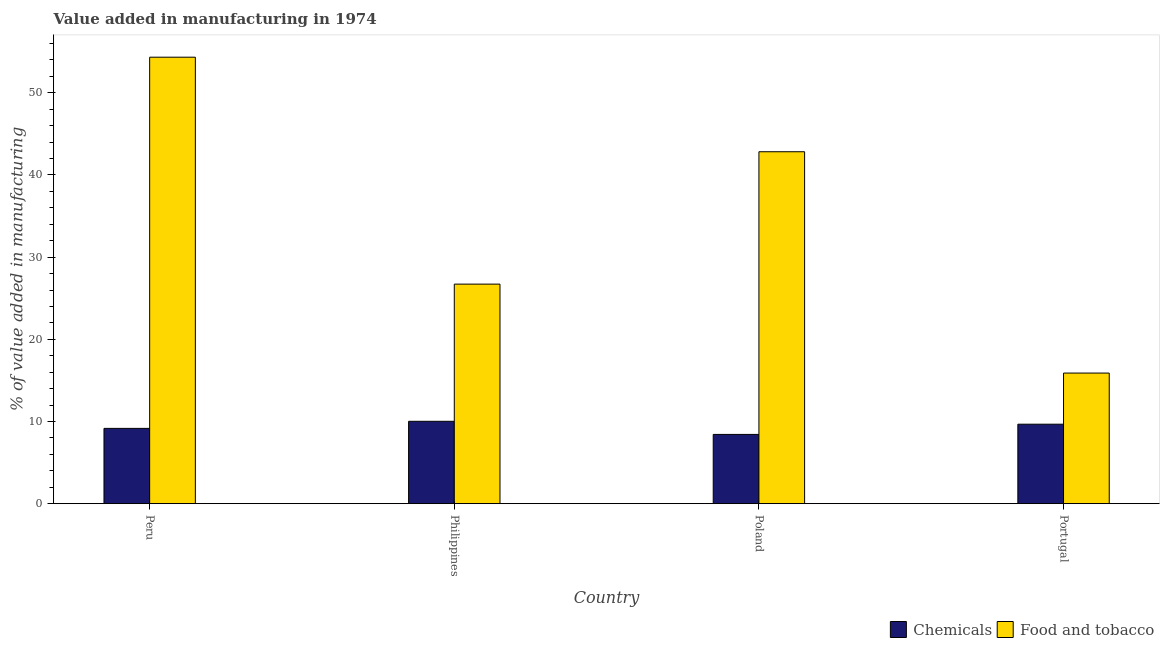How many different coloured bars are there?
Provide a succinct answer. 2. How many groups of bars are there?
Offer a terse response. 4. Are the number of bars on each tick of the X-axis equal?
Give a very brief answer. Yes. How many bars are there on the 2nd tick from the left?
Provide a short and direct response. 2. What is the label of the 3rd group of bars from the left?
Keep it short and to the point. Poland. What is the value added by  manufacturing chemicals in Philippines?
Offer a very short reply. 10.02. Across all countries, what is the maximum value added by manufacturing food and tobacco?
Provide a short and direct response. 54.33. Across all countries, what is the minimum value added by  manufacturing chemicals?
Your response must be concise. 8.43. In which country was the value added by manufacturing food and tobacco maximum?
Provide a short and direct response. Peru. What is the total value added by manufacturing food and tobacco in the graph?
Keep it short and to the point. 139.77. What is the difference between the value added by  manufacturing chemicals in Poland and that in Portugal?
Make the answer very short. -1.24. What is the difference between the value added by manufacturing food and tobacco in Peru and the value added by  manufacturing chemicals in Philippines?
Your response must be concise. 44.31. What is the average value added by  manufacturing chemicals per country?
Your answer should be very brief. 9.32. What is the difference between the value added by  manufacturing chemicals and value added by manufacturing food and tobacco in Portugal?
Your answer should be compact. -6.22. In how many countries, is the value added by  manufacturing chemicals greater than 40 %?
Provide a short and direct response. 0. What is the ratio of the value added by manufacturing food and tobacco in Peru to that in Portugal?
Your response must be concise. 3.42. What is the difference between the highest and the second highest value added by manufacturing food and tobacco?
Your response must be concise. 11.51. What is the difference between the highest and the lowest value added by  manufacturing chemicals?
Provide a short and direct response. 1.59. In how many countries, is the value added by  manufacturing chemicals greater than the average value added by  manufacturing chemicals taken over all countries?
Give a very brief answer. 2. What does the 1st bar from the left in Philippines represents?
Your answer should be very brief. Chemicals. What does the 2nd bar from the right in Peru represents?
Your answer should be compact. Chemicals. Are all the bars in the graph horizontal?
Make the answer very short. No. How many countries are there in the graph?
Your answer should be compact. 4. What is the difference between two consecutive major ticks on the Y-axis?
Provide a short and direct response. 10. Are the values on the major ticks of Y-axis written in scientific E-notation?
Provide a short and direct response. No. Where does the legend appear in the graph?
Make the answer very short. Bottom right. How are the legend labels stacked?
Keep it short and to the point. Horizontal. What is the title of the graph?
Your answer should be very brief. Value added in manufacturing in 1974. What is the label or title of the X-axis?
Offer a very short reply. Country. What is the label or title of the Y-axis?
Ensure brevity in your answer.  % of value added in manufacturing. What is the % of value added in manufacturing of Chemicals in Peru?
Provide a short and direct response. 9.16. What is the % of value added in manufacturing in Food and tobacco in Peru?
Provide a short and direct response. 54.33. What is the % of value added in manufacturing of Chemicals in Philippines?
Ensure brevity in your answer.  10.02. What is the % of value added in manufacturing in Food and tobacco in Philippines?
Your response must be concise. 26.72. What is the % of value added in manufacturing in Chemicals in Poland?
Offer a very short reply. 8.43. What is the % of value added in manufacturing in Food and tobacco in Poland?
Offer a terse response. 42.83. What is the % of value added in manufacturing in Chemicals in Portugal?
Offer a very short reply. 9.67. What is the % of value added in manufacturing in Food and tobacco in Portugal?
Your answer should be compact. 15.89. Across all countries, what is the maximum % of value added in manufacturing of Chemicals?
Your response must be concise. 10.02. Across all countries, what is the maximum % of value added in manufacturing of Food and tobacco?
Offer a terse response. 54.33. Across all countries, what is the minimum % of value added in manufacturing of Chemicals?
Ensure brevity in your answer.  8.43. Across all countries, what is the minimum % of value added in manufacturing of Food and tobacco?
Your answer should be compact. 15.89. What is the total % of value added in manufacturing of Chemicals in the graph?
Ensure brevity in your answer.  37.28. What is the total % of value added in manufacturing of Food and tobacco in the graph?
Your answer should be compact. 139.77. What is the difference between the % of value added in manufacturing in Chemicals in Peru and that in Philippines?
Make the answer very short. -0.86. What is the difference between the % of value added in manufacturing of Food and tobacco in Peru and that in Philippines?
Your response must be concise. 27.61. What is the difference between the % of value added in manufacturing of Chemicals in Peru and that in Poland?
Your response must be concise. 0.73. What is the difference between the % of value added in manufacturing in Food and tobacco in Peru and that in Poland?
Offer a terse response. 11.51. What is the difference between the % of value added in manufacturing of Chemicals in Peru and that in Portugal?
Ensure brevity in your answer.  -0.51. What is the difference between the % of value added in manufacturing of Food and tobacco in Peru and that in Portugal?
Offer a very short reply. 38.44. What is the difference between the % of value added in manufacturing of Chemicals in Philippines and that in Poland?
Ensure brevity in your answer.  1.59. What is the difference between the % of value added in manufacturing of Food and tobacco in Philippines and that in Poland?
Make the answer very short. -16.11. What is the difference between the % of value added in manufacturing of Chemicals in Philippines and that in Portugal?
Offer a terse response. 0.35. What is the difference between the % of value added in manufacturing of Food and tobacco in Philippines and that in Portugal?
Provide a short and direct response. 10.83. What is the difference between the % of value added in manufacturing of Chemicals in Poland and that in Portugal?
Offer a terse response. -1.24. What is the difference between the % of value added in manufacturing of Food and tobacco in Poland and that in Portugal?
Offer a very short reply. 26.94. What is the difference between the % of value added in manufacturing of Chemicals in Peru and the % of value added in manufacturing of Food and tobacco in Philippines?
Your answer should be very brief. -17.56. What is the difference between the % of value added in manufacturing in Chemicals in Peru and the % of value added in manufacturing in Food and tobacco in Poland?
Keep it short and to the point. -33.67. What is the difference between the % of value added in manufacturing in Chemicals in Peru and the % of value added in manufacturing in Food and tobacco in Portugal?
Ensure brevity in your answer.  -6.73. What is the difference between the % of value added in manufacturing of Chemicals in Philippines and the % of value added in manufacturing of Food and tobacco in Poland?
Provide a short and direct response. -32.8. What is the difference between the % of value added in manufacturing of Chemicals in Philippines and the % of value added in manufacturing of Food and tobacco in Portugal?
Your response must be concise. -5.87. What is the difference between the % of value added in manufacturing of Chemicals in Poland and the % of value added in manufacturing of Food and tobacco in Portugal?
Your answer should be very brief. -7.46. What is the average % of value added in manufacturing in Chemicals per country?
Keep it short and to the point. 9.32. What is the average % of value added in manufacturing in Food and tobacco per country?
Provide a succinct answer. 34.94. What is the difference between the % of value added in manufacturing of Chemicals and % of value added in manufacturing of Food and tobacco in Peru?
Provide a short and direct response. -45.17. What is the difference between the % of value added in manufacturing in Chemicals and % of value added in manufacturing in Food and tobacco in Philippines?
Provide a succinct answer. -16.7. What is the difference between the % of value added in manufacturing of Chemicals and % of value added in manufacturing of Food and tobacco in Poland?
Ensure brevity in your answer.  -34.4. What is the difference between the % of value added in manufacturing in Chemicals and % of value added in manufacturing in Food and tobacco in Portugal?
Offer a terse response. -6.22. What is the ratio of the % of value added in manufacturing in Chemicals in Peru to that in Philippines?
Your answer should be very brief. 0.91. What is the ratio of the % of value added in manufacturing in Food and tobacco in Peru to that in Philippines?
Give a very brief answer. 2.03. What is the ratio of the % of value added in manufacturing of Chemicals in Peru to that in Poland?
Your response must be concise. 1.09. What is the ratio of the % of value added in manufacturing of Food and tobacco in Peru to that in Poland?
Offer a terse response. 1.27. What is the ratio of the % of value added in manufacturing of Food and tobacco in Peru to that in Portugal?
Make the answer very short. 3.42. What is the ratio of the % of value added in manufacturing of Chemicals in Philippines to that in Poland?
Your answer should be compact. 1.19. What is the ratio of the % of value added in manufacturing in Food and tobacco in Philippines to that in Poland?
Keep it short and to the point. 0.62. What is the ratio of the % of value added in manufacturing in Chemicals in Philippines to that in Portugal?
Ensure brevity in your answer.  1.04. What is the ratio of the % of value added in manufacturing in Food and tobacco in Philippines to that in Portugal?
Offer a terse response. 1.68. What is the ratio of the % of value added in manufacturing of Chemicals in Poland to that in Portugal?
Give a very brief answer. 0.87. What is the ratio of the % of value added in manufacturing in Food and tobacco in Poland to that in Portugal?
Your answer should be very brief. 2.69. What is the difference between the highest and the second highest % of value added in manufacturing of Chemicals?
Ensure brevity in your answer.  0.35. What is the difference between the highest and the second highest % of value added in manufacturing of Food and tobacco?
Offer a terse response. 11.51. What is the difference between the highest and the lowest % of value added in manufacturing of Chemicals?
Your response must be concise. 1.59. What is the difference between the highest and the lowest % of value added in manufacturing of Food and tobacco?
Provide a succinct answer. 38.44. 